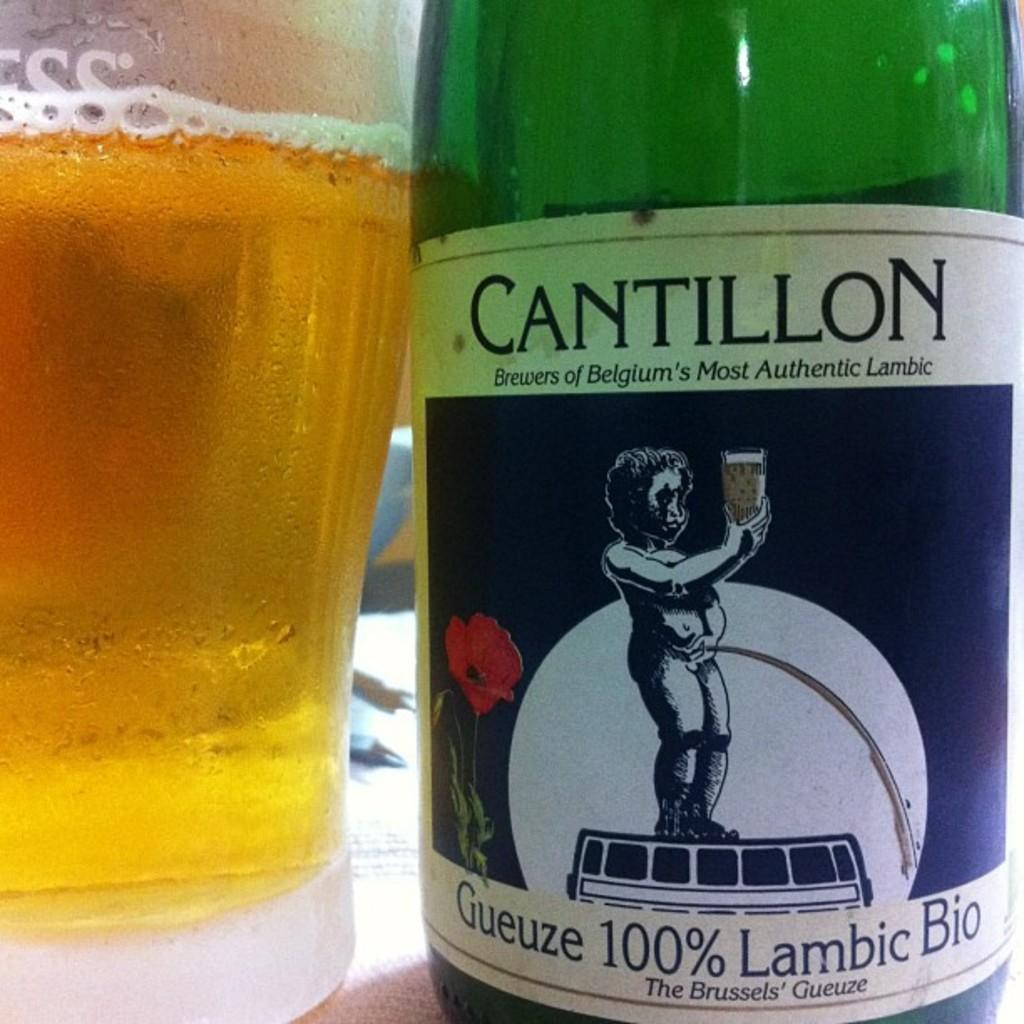<image>
Render a clear and concise summary of the photo. Bottle of Cantillon brewers of Belgium's Most Authentic Lambic drink 